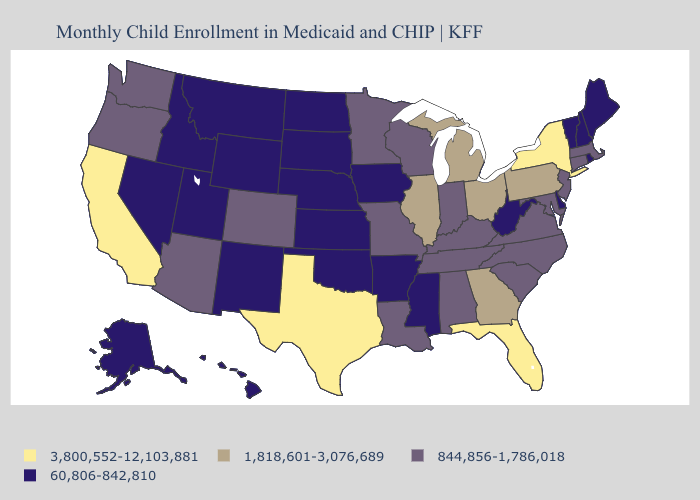Does Illinois have the same value as Tennessee?
Answer briefly. No. Name the states that have a value in the range 1,818,601-3,076,689?
Short answer required. Georgia, Illinois, Michigan, Ohio, Pennsylvania. Which states have the lowest value in the USA?
Give a very brief answer. Alaska, Arkansas, Delaware, Hawaii, Idaho, Iowa, Kansas, Maine, Mississippi, Montana, Nebraska, Nevada, New Hampshire, New Mexico, North Dakota, Oklahoma, Rhode Island, South Dakota, Utah, Vermont, West Virginia, Wyoming. What is the value of Alaska?
Write a very short answer. 60,806-842,810. Does the first symbol in the legend represent the smallest category?
Short answer required. No. What is the value of Pennsylvania?
Be succinct. 1,818,601-3,076,689. What is the value of Wyoming?
Concise answer only. 60,806-842,810. What is the value of South Carolina?
Keep it brief. 844,856-1,786,018. Name the states that have a value in the range 1,818,601-3,076,689?
Quick response, please. Georgia, Illinois, Michigan, Ohio, Pennsylvania. Name the states that have a value in the range 60,806-842,810?
Concise answer only. Alaska, Arkansas, Delaware, Hawaii, Idaho, Iowa, Kansas, Maine, Mississippi, Montana, Nebraska, Nevada, New Hampshire, New Mexico, North Dakota, Oklahoma, Rhode Island, South Dakota, Utah, Vermont, West Virginia, Wyoming. Name the states that have a value in the range 60,806-842,810?
Concise answer only. Alaska, Arkansas, Delaware, Hawaii, Idaho, Iowa, Kansas, Maine, Mississippi, Montana, Nebraska, Nevada, New Hampshire, New Mexico, North Dakota, Oklahoma, Rhode Island, South Dakota, Utah, Vermont, West Virginia, Wyoming. What is the lowest value in the MidWest?
Give a very brief answer. 60,806-842,810. Name the states that have a value in the range 3,800,552-12,103,881?
Short answer required. California, Florida, New York, Texas. Name the states that have a value in the range 60,806-842,810?
Keep it brief. Alaska, Arkansas, Delaware, Hawaii, Idaho, Iowa, Kansas, Maine, Mississippi, Montana, Nebraska, Nevada, New Hampshire, New Mexico, North Dakota, Oklahoma, Rhode Island, South Dakota, Utah, Vermont, West Virginia, Wyoming. Name the states that have a value in the range 844,856-1,786,018?
Be succinct. Alabama, Arizona, Colorado, Connecticut, Indiana, Kentucky, Louisiana, Maryland, Massachusetts, Minnesota, Missouri, New Jersey, North Carolina, Oregon, South Carolina, Tennessee, Virginia, Washington, Wisconsin. 